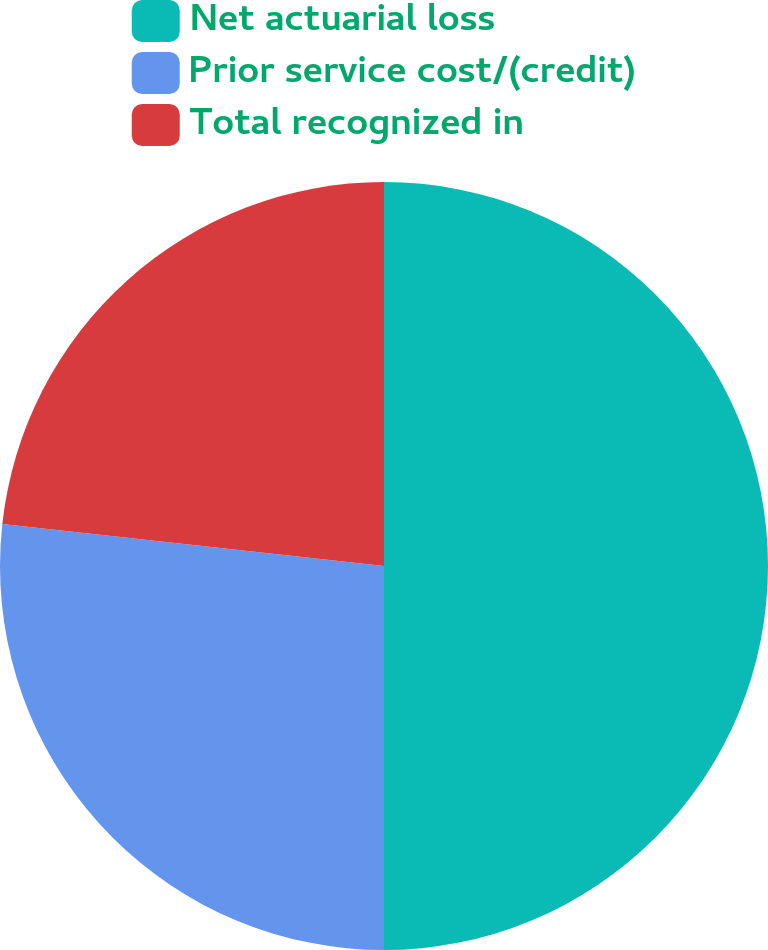Convert chart to OTSL. <chart><loc_0><loc_0><loc_500><loc_500><pie_chart><fcel>Net actuarial loss<fcel>Prior service cost/(credit)<fcel>Total recognized in<nl><fcel>50.0%<fcel>26.74%<fcel>23.26%<nl></chart> 